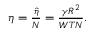Convert formula to latex. <formula><loc_0><loc_0><loc_500><loc_500>\begin{array} { r } { \eta = \frac { \hat { \eta } } { N } = \frac { \gamma R ^ { 2 } } { W T N } . } \end{array}</formula> 